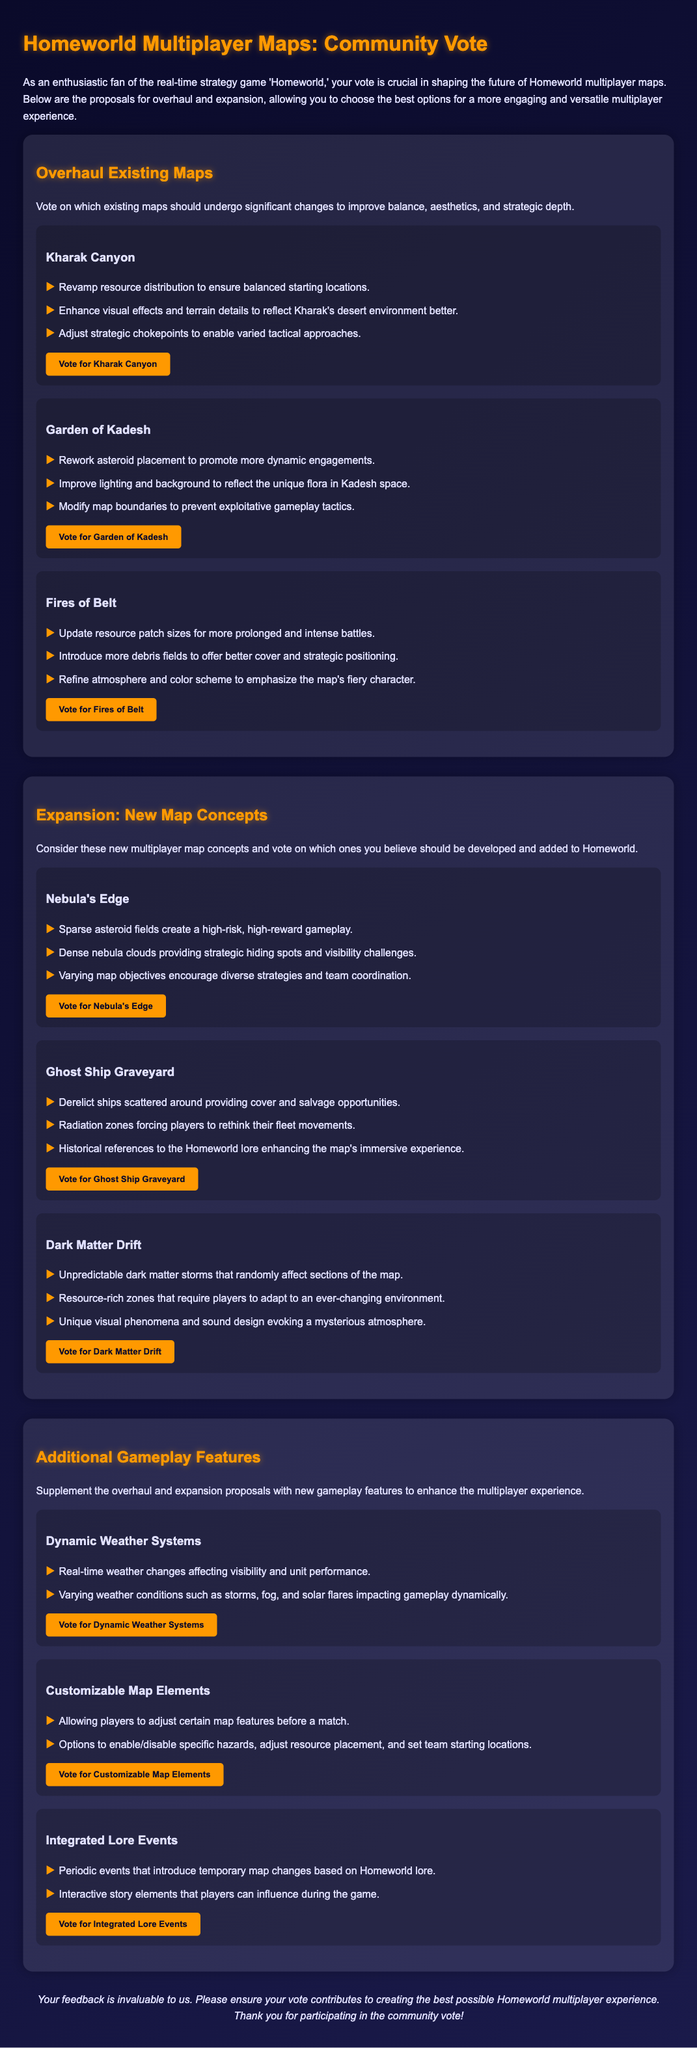what map received a proposal for revamping resource distribution? The document states that Kharak Canyon will undergo significant changes to improve balance, including revamping resource distribution.
Answer: Kharak Canyon how many new map concepts are proposed? The document lists three new map concepts under the Expansion section, which total to three.
Answer: 3 what gameplay feature involves real-time weather changes? The document lists Dynamic Weather Systems as a proposed gameplay feature affecting visibility and unit performance with real-time changes.
Answer: Dynamic Weather Systems which map concept includes derelict ships? The proposal for Ghost Ship Graveyard includes derelict ships as part of the gameplay.
Answer: Ghost Ship Graveyard what should be adjusted to promote more dynamic engagements on the Garden of Kadesh map? The proposal suggests reworking asteroid placement to promote more dynamic engagements.
Answer: Asteroid placement what additional gameplay feature allows customization before a match? The document states that Customizable Map Elements will allow players to adjust certain features before a match.
Answer: Customizable Map Elements how does the Goblin Ship Graveyard enhance immersion? The proposal notes that historical references to the Homeworld lore will enhance the immersive experience of the Ghost Ship Graveyard map.
Answer: Historical references which existing map proposal intends to introduce more debris fields? The Fires of Belt proposal includes an update to introduce more debris fields for better cover and strategic positioning.
Answer: Fires of Belt what are the two primary benefits of the Dark Matter Drift map concept? The Dark Matter Drift concept features unpredictable storms that affect gameplay and resource-rich zones, requiring adaptation.
Answer: Unpredictable storms and resource-rich zones 